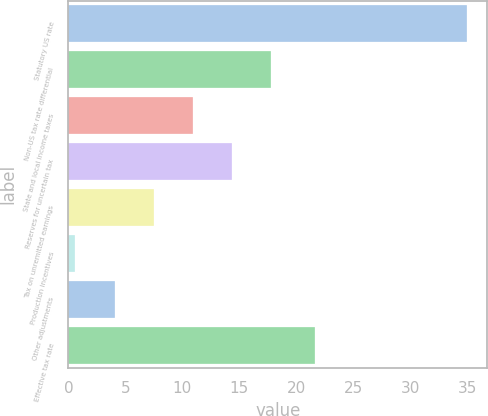Convert chart. <chart><loc_0><loc_0><loc_500><loc_500><bar_chart><fcel>Statutory US rate<fcel>Non-US tax rate differential<fcel>State and local income taxes<fcel>Reserves for uncertain tax<fcel>Tax on unremitted earnings<fcel>Production incentives<fcel>Other adjustments<fcel>Effective tax rate<nl><fcel>35<fcel>17.8<fcel>10.92<fcel>14.36<fcel>7.48<fcel>0.6<fcel>4.04<fcel>21.6<nl></chart> 